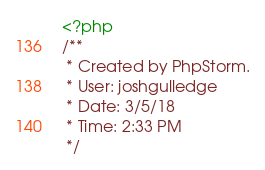<code> <loc_0><loc_0><loc_500><loc_500><_PHP_><?php
/**
 * Created by PhpStorm.
 * User: joshgulledge
 * Date: 3/5/18
 * Time: 2:33 PM
 */
</code> 